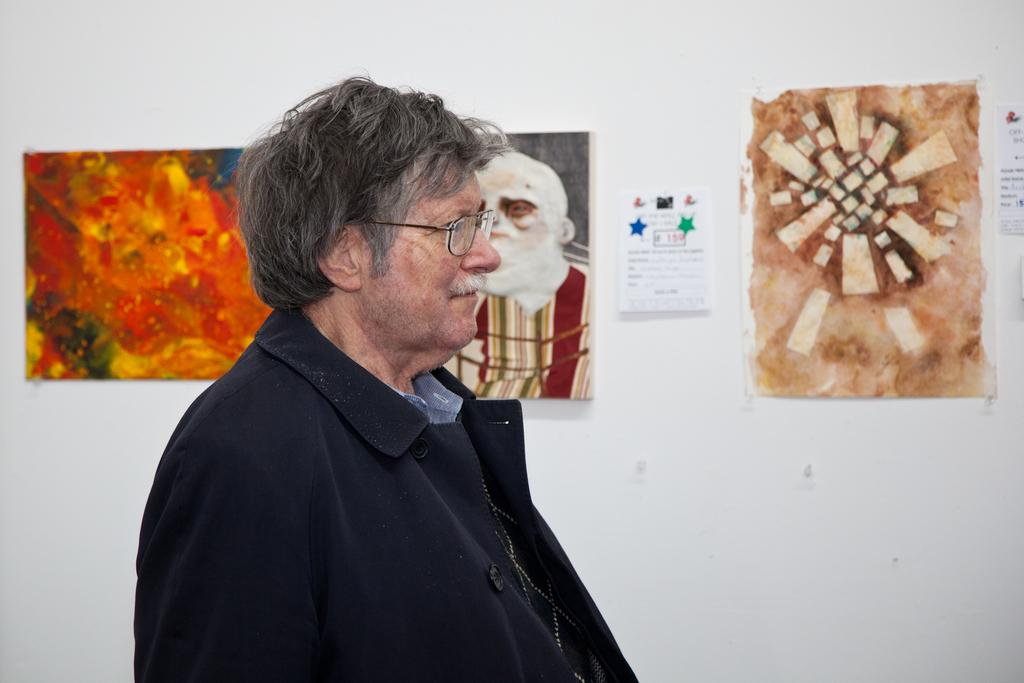Who is the main subject in the image? There is an old man in the image. What is the old man wearing? The old man is wearing a black coat. Where is the old man located in the image? The old man is in the middle of the image. What can be seen in the background of the image? There is a wall in the background of the image. What is on the wall in the image? There are posters and frames on the wall. What type of machine is the old man using in the image? There is no machine present in the image; the old man is simply standing in the middle of the image. 